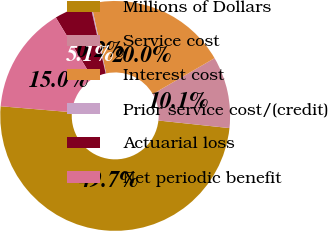<chart> <loc_0><loc_0><loc_500><loc_500><pie_chart><fcel>Millions of Dollars<fcel>Service cost<fcel>Interest cost<fcel>Prior service cost/(credit)<fcel>Actuarial loss<fcel>Net periodic benefit<nl><fcel>49.65%<fcel>10.07%<fcel>19.97%<fcel>0.17%<fcel>5.12%<fcel>15.02%<nl></chart> 